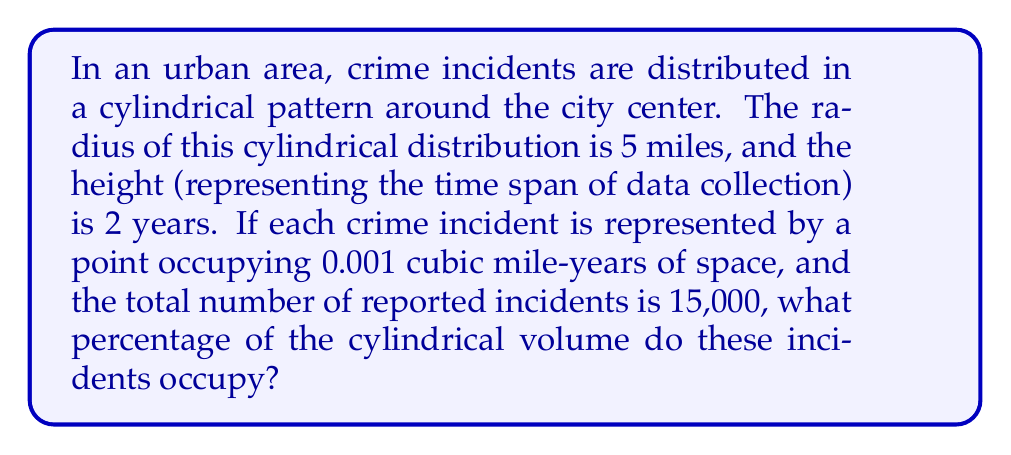Teach me how to tackle this problem. To solve this problem, let's follow these steps:

1. Calculate the volume of the cylindrical distribution:
   $$V_{cylinder} = \pi r^2 h$$
   Where $r$ is the radius and $h$ is the height.
   $$V_{cylinder} = \pi (5\text{ miles})^2 (2\text{ years}) = 50\pi\text{ mile}^2\text{-years}$$

2. Calculate the total volume occupied by all crime incidents:
   $$V_{incidents} = 15,000 \times 0.001\text{ cubic mile-years} = 15\text{ cubic mile-years}$$

3. Calculate the percentage of the cylindrical volume occupied by the incidents:
   $$\text{Percentage} = \frac{V_{incidents}}{V_{cylinder}} \times 100\%$$
   $$= \frac{15\text{ cubic mile-years}}{50\pi\text{ mile}^2\text{-years}} \times 100\%$$
   $$= \frac{15}{50\pi} \times 100\% = \frac{3}{10\pi} \times 100\% \approx 9.55\%$$
Answer: 9.55% 